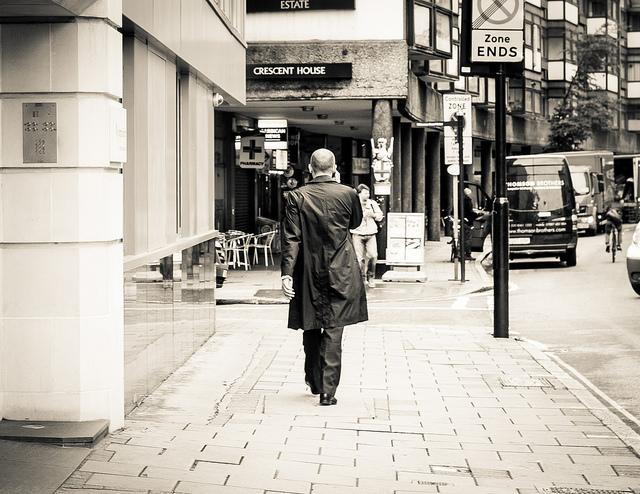During what time of day are the pedestrians walking on this sidewalk?

Choices:
A) evening
B) morning
C) night
D) noon morning 